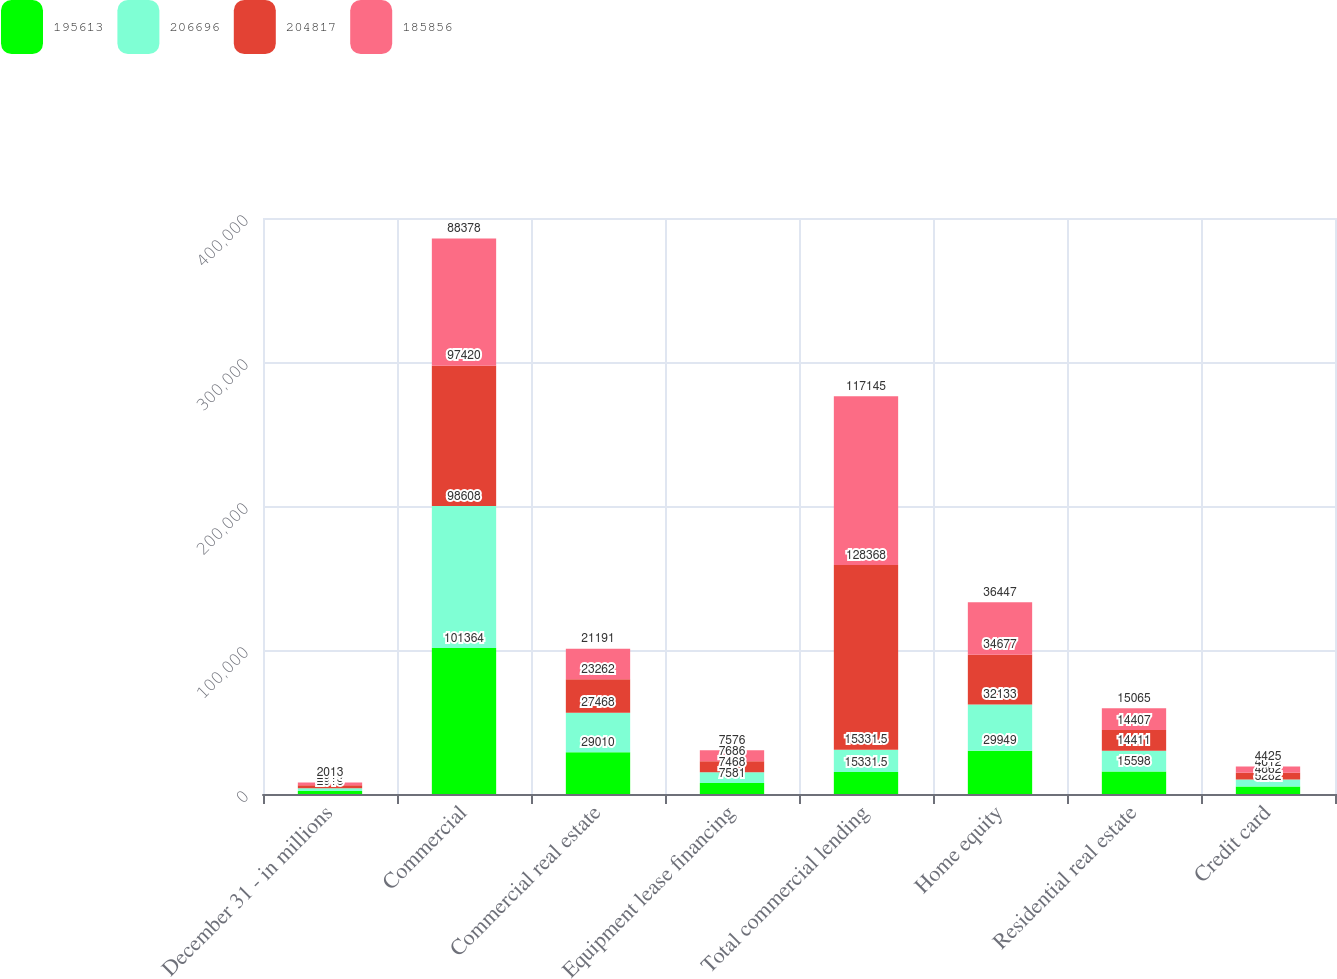<chart> <loc_0><loc_0><loc_500><loc_500><stacked_bar_chart><ecel><fcel>December 31 - in millions<fcel>Commercial<fcel>Commercial real estate<fcel>Equipment lease financing<fcel>Total commercial lending<fcel>Home equity<fcel>Residential real estate<fcel>Credit card<nl><fcel>195613<fcel>2016<fcel>101364<fcel>29010<fcel>7581<fcel>15331.5<fcel>29949<fcel>15598<fcel>5282<nl><fcel>206696<fcel>2015<fcel>98608<fcel>27468<fcel>7468<fcel>15331.5<fcel>32133<fcel>14411<fcel>4862<nl><fcel>204817<fcel>2014<fcel>97420<fcel>23262<fcel>7686<fcel>128368<fcel>34677<fcel>14407<fcel>4612<nl><fcel>185856<fcel>2013<fcel>88378<fcel>21191<fcel>7576<fcel>117145<fcel>36447<fcel>15065<fcel>4425<nl></chart> 